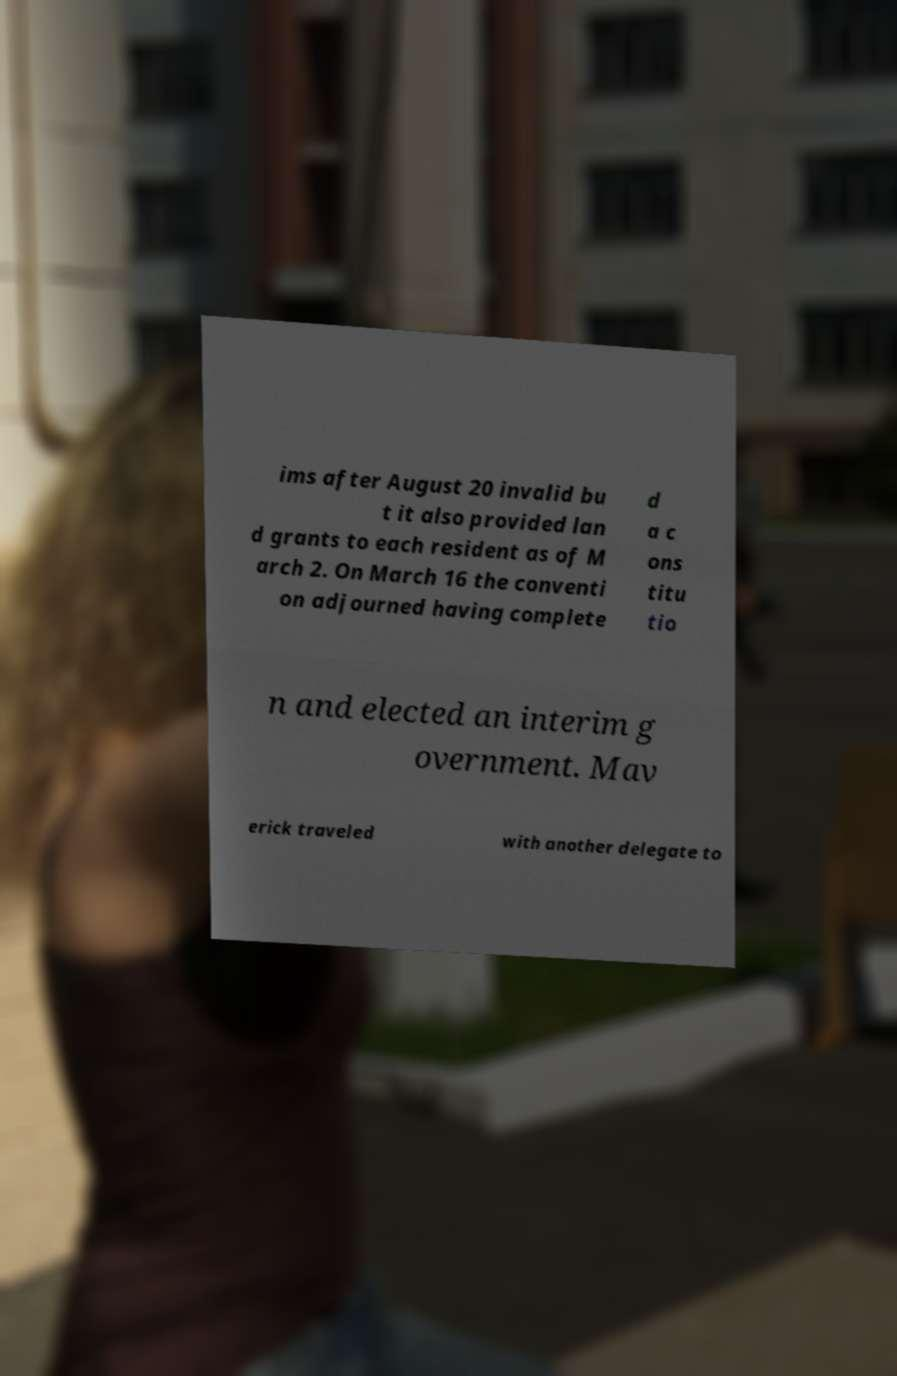For documentation purposes, I need the text within this image transcribed. Could you provide that? ims after August 20 invalid bu t it also provided lan d grants to each resident as of M arch 2. On March 16 the conventi on adjourned having complete d a c ons titu tio n and elected an interim g overnment. Mav erick traveled with another delegate to 